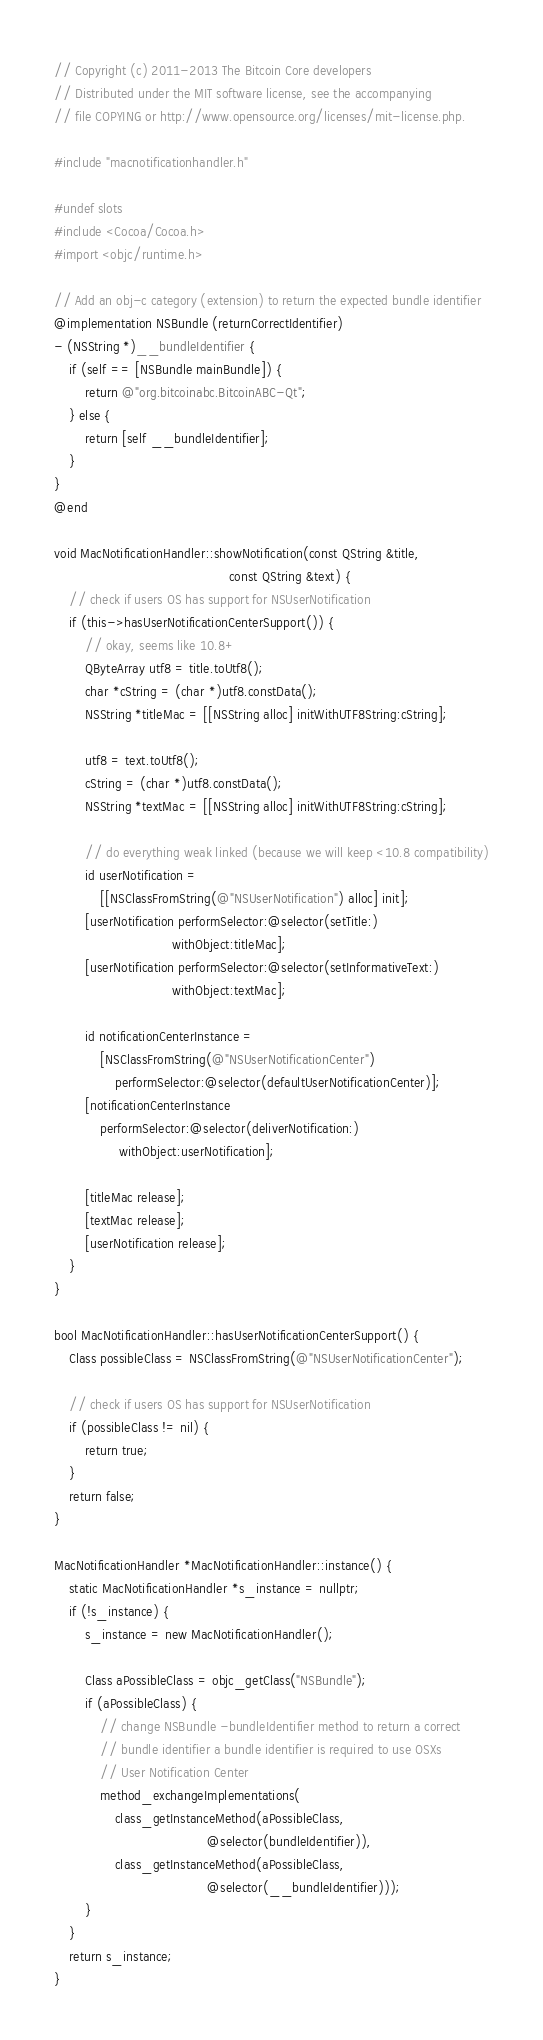<code> <loc_0><loc_0><loc_500><loc_500><_ObjectiveC_>// Copyright (c) 2011-2013 The Bitcoin Core developers
// Distributed under the MIT software license, see the accompanying
// file COPYING or http://www.opensource.org/licenses/mit-license.php.

#include "macnotificationhandler.h"

#undef slots
#include <Cocoa/Cocoa.h>
#import <objc/runtime.h>

// Add an obj-c category (extension) to return the expected bundle identifier
@implementation NSBundle (returnCorrectIdentifier)
- (NSString *)__bundleIdentifier {
    if (self == [NSBundle mainBundle]) {
        return @"org.bitcoinabc.BitcoinABC-Qt";
    } else {
        return [self __bundleIdentifier];
    }
}
@end

void MacNotificationHandler::showNotification(const QString &title,
                                              const QString &text) {
    // check if users OS has support for NSUserNotification
    if (this->hasUserNotificationCenterSupport()) {
        // okay, seems like 10.8+
        QByteArray utf8 = title.toUtf8();
        char *cString = (char *)utf8.constData();
        NSString *titleMac = [[NSString alloc] initWithUTF8String:cString];

        utf8 = text.toUtf8();
        cString = (char *)utf8.constData();
        NSString *textMac = [[NSString alloc] initWithUTF8String:cString];

        // do everything weak linked (because we will keep <10.8 compatibility)
        id userNotification =
            [[NSClassFromString(@"NSUserNotification") alloc] init];
        [userNotification performSelector:@selector(setTitle:)
                               withObject:titleMac];
        [userNotification performSelector:@selector(setInformativeText:)
                               withObject:textMac];

        id notificationCenterInstance =
            [NSClassFromString(@"NSUserNotificationCenter")
                performSelector:@selector(defaultUserNotificationCenter)];
        [notificationCenterInstance
            performSelector:@selector(deliverNotification:)
                 withObject:userNotification];

        [titleMac release];
        [textMac release];
        [userNotification release];
    }
}

bool MacNotificationHandler::hasUserNotificationCenterSupport() {
    Class possibleClass = NSClassFromString(@"NSUserNotificationCenter");

    // check if users OS has support for NSUserNotification
    if (possibleClass != nil) {
        return true;
    }
    return false;
}

MacNotificationHandler *MacNotificationHandler::instance() {
    static MacNotificationHandler *s_instance = nullptr;
    if (!s_instance) {
        s_instance = new MacNotificationHandler();

        Class aPossibleClass = objc_getClass("NSBundle");
        if (aPossibleClass) {
            // change NSBundle -bundleIdentifier method to return a correct
            // bundle identifier a bundle identifier is required to use OSXs
            // User Notification Center
            method_exchangeImplementations(
                class_getInstanceMethod(aPossibleClass,
                                        @selector(bundleIdentifier)),
                class_getInstanceMethod(aPossibleClass,
                                        @selector(__bundleIdentifier)));
        }
    }
    return s_instance;
}
</code> 